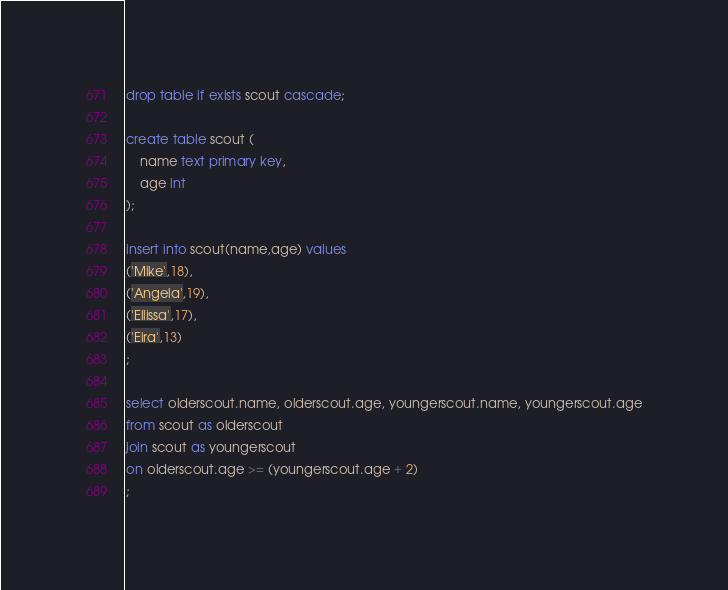Convert code to text. <code><loc_0><loc_0><loc_500><loc_500><_SQL_>drop table if exists scout cascade;

create table scout (
    name text primary key,
    age int
);

insert into scout(name,age) values 
('Mike',18),
('Angela',19),
('Ellissa',17),
('Eira',13)
;

select olderscout.name, olderscout.age, youngerscout.name, youngerscout.age
from scout as olderscout
join scout as youngerscout
on olderscout.age >= (youngerscout.age + 2)
;

</code> 